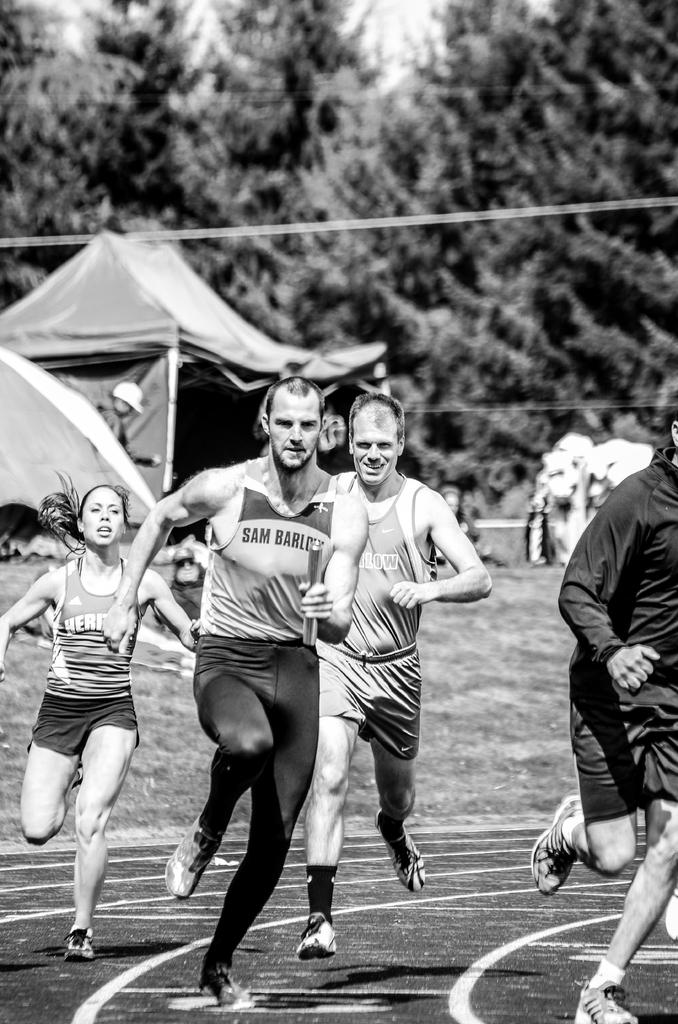What is the color scheme of the image? The image is black and white. What are the persons in the foreground doing? The persons in the foreground are running on the ground. What can be observed about the ground in the image? The ground has lines on it. Can you describe the background of the image? In the background, there are persons visible, as well as trees and the sky. What type of education can be seen taking place in the image? There is no indication of education taking place in the image; it features persons running on a ground with lines. How is the knot tied in the image? There is no knot present in the image. 